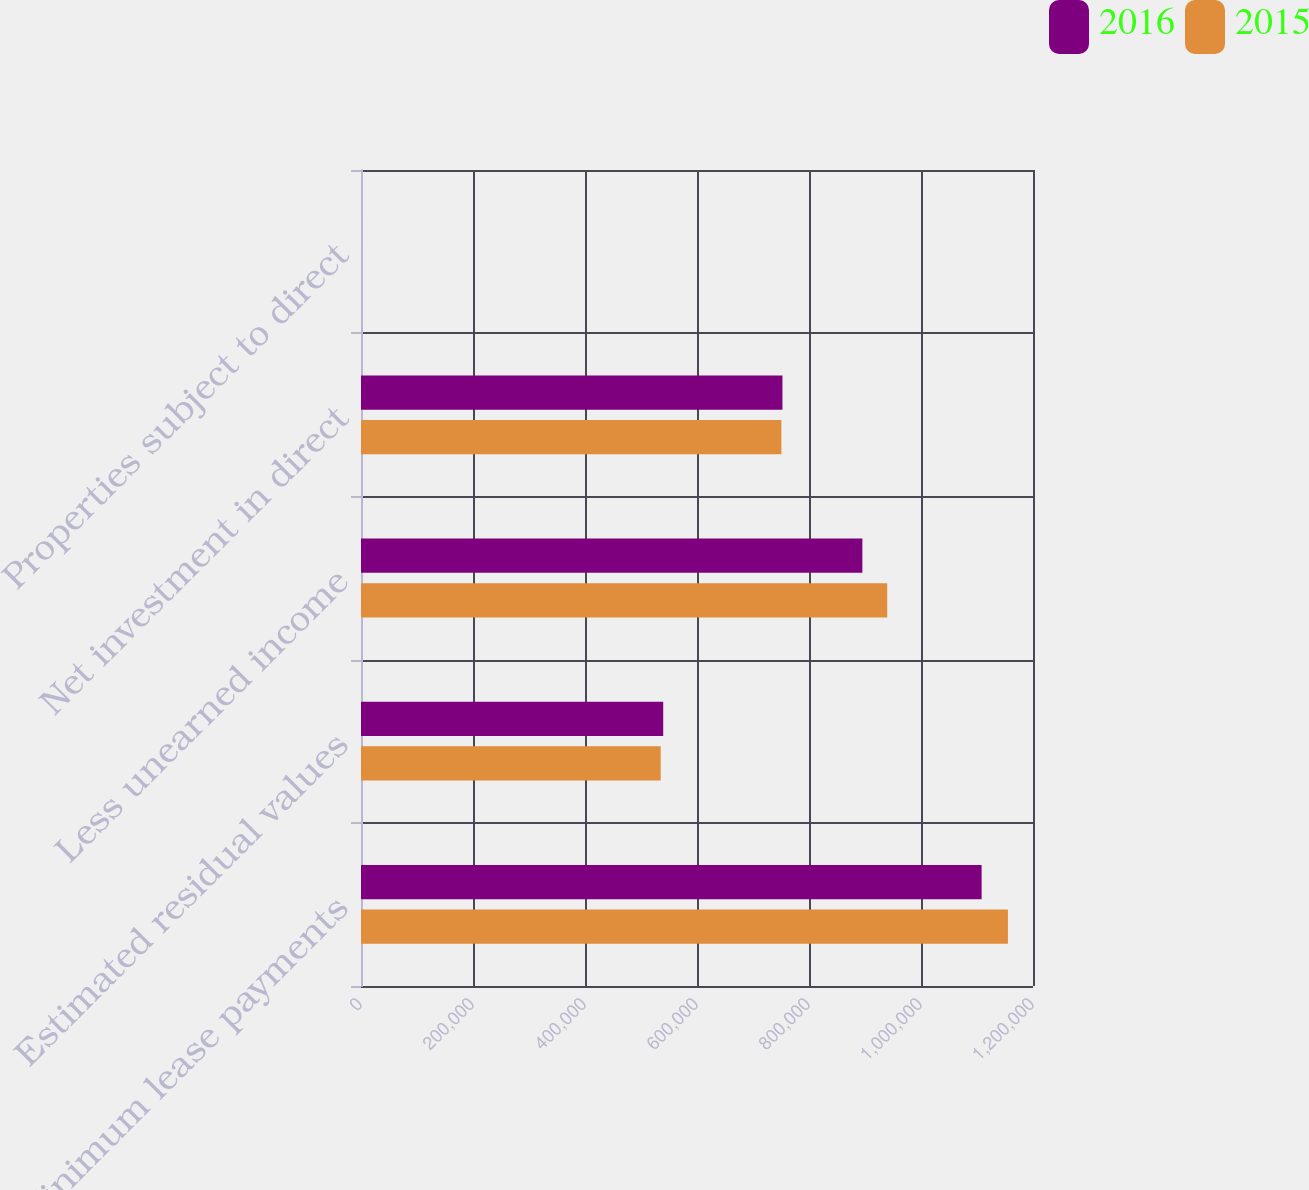<chart> <loc_0><loc_0><loc_500><loc_500><stacked_bar_chart><ecel><fcel>Minimum lease payments<fcel>Estimated residual values<fcel>Less unearned income<fcel>Net investment in direct<fcel>Properties subject to direct<nl><fcel>2016<fcel>1.10824e+06<fcel>539656<fcel>895304<fcel>752589<fcel>30<nl><fcel>2015<fcel>1.15522e+06<fcel>535161<fcel>939683<fcel>750693<fcel>30<nl></chart> 